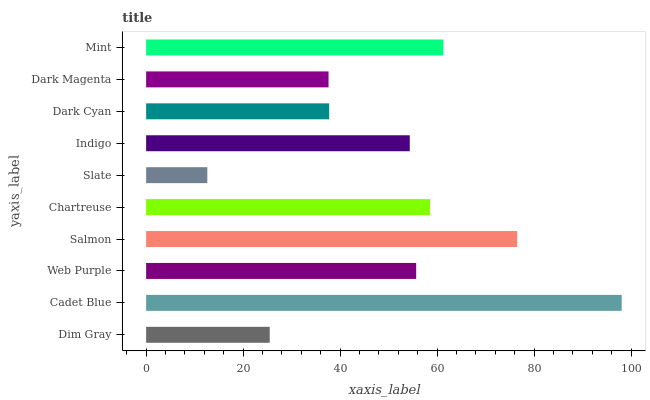Is Slate the minimum?
Answer yes or no. Yes. Is Cadet Blue the maximum?
Answer yes or no. Yes. Is Web Purple the minimum?
Answer yes or no. No. Is Web Purple the maximum?
Answer yes or no. No. Is Cadet Blue greater than Web Purple?
Answer yes or no. Yes. Is Web Purple less than Cadet Blue?
Answer yes or no. Yes. Is Web Purple greater than Cadet Blue?
Answer yes or no. No. Is Cadet Blue less than Web Purple?
Answer yes or no. No. Is Web Purple the high median?
Answer yes or no. Yes. Is Indigo the low median?
Answer yes or no. Yes. Is Dim Gray the high median?
Answer yes or no. No. Is Salmon the low median?
Answer yes or no. No. 